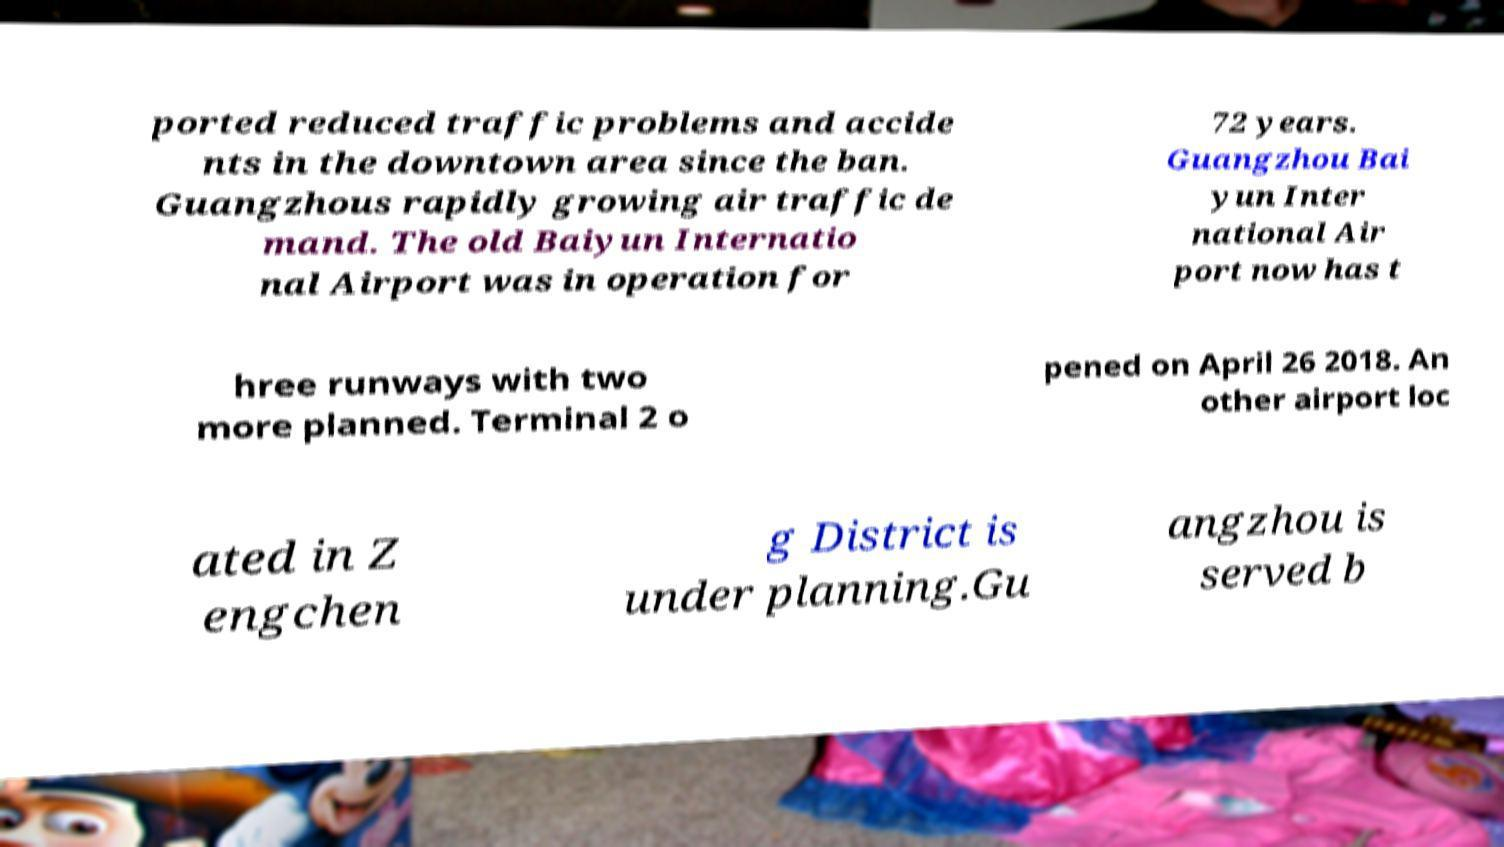Could you extract and type out the text from this image? ported reduced traffic problems and accide nts in the downtown area since the ban. Guangzhous rapidly growing air traffic de mand. The old Baiyun Internatio nal Airport was in operation for 72 years. Guangzhou Bai yun Inter national Air port now has t hree runways with two more planned. Terminal 2 o pened on April 26 2018. An other airport loc ated in Z engchen g District is under planning.Gu angzhou is served b 